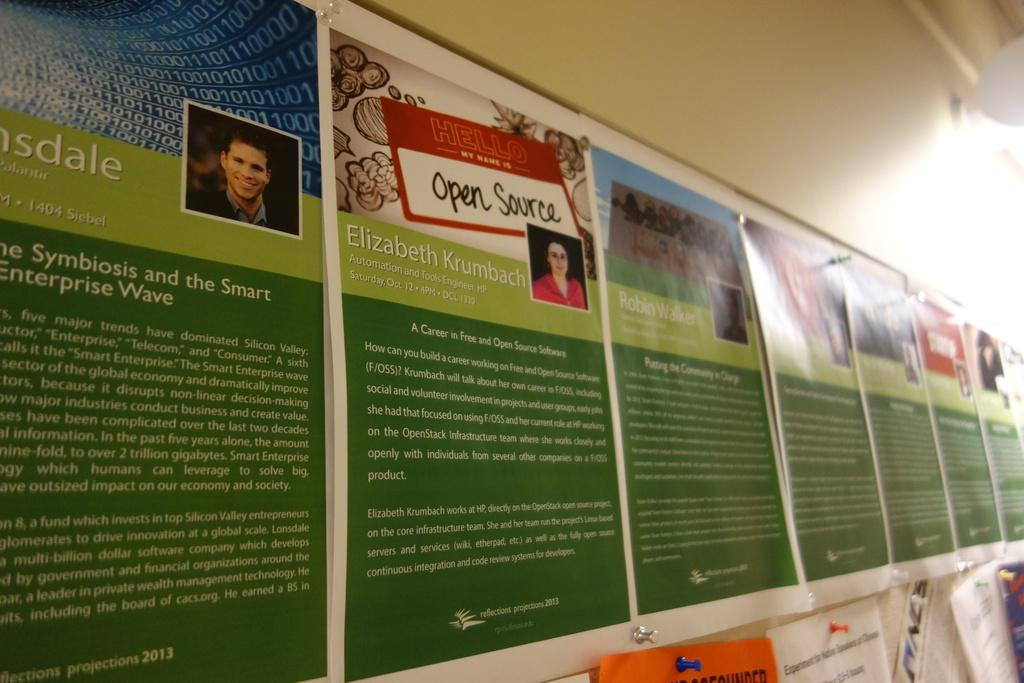What is located in the foreground of the image? There is a notice board in the foreground of the image. What is attached to the notice board? There are posters on the notice board. Can you describe the light in the image? There is a light in the image, but its specific characteristics are not mentioned. What is visible behind the notice board? There is a wall in the image. How many stalks of celery are visible on the notice board? There is no celery present on the notice board in the image. What is the value of the posters on the notice board? The value of the posters cannot be determined from the image alone, as it depends on their content and context. 